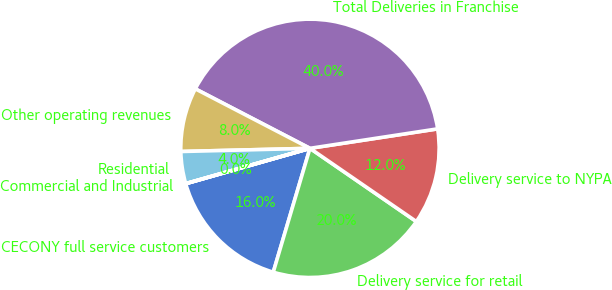Convert chart to OTSL. <chart><loc_0><loc_0><loc_500><loc_500><pie_chart><fcel>CECONY full service customers<fcel>Delivery service for retail<fcel>Delivery service to NYPA<fcel>Total Deliveries in Franchise<fcel>Other operating revenues<fcel>Residential<fcel>Commercial and Industrial<nl><fcel>16.0%<fcel>19.99%<fcel>12.0%<fcel>39.97%<fcel>8.01%<fcel>4.01%<fcel>0.01%<nl></chart> 